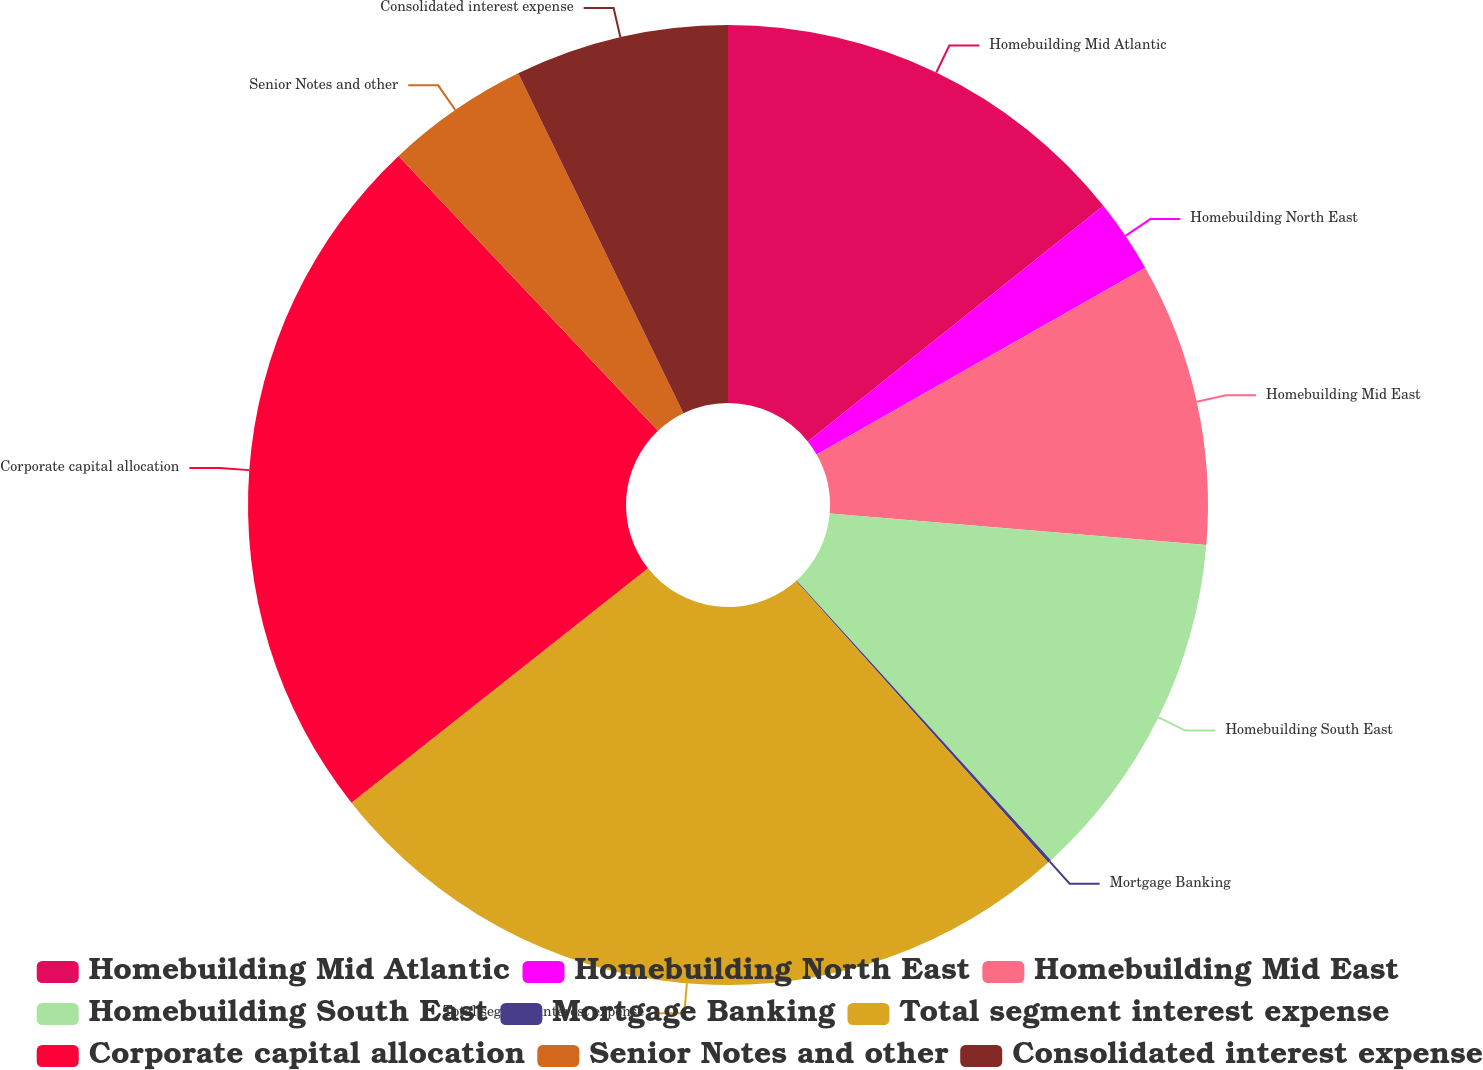<chart> <loc_0><loc_0><loc_500><loc_500><pie_chart><fcel>Homebuilding Mid Atlantic<fcel>Homebuilding North East<fcel>Homebuilding Mid East<fcel>Homebuilding South East<fcel>Mortgage Banking<fcel>Total segment interest expense<fcel>Corporate capital allocation<fcel>Senior Notes and other<fcel>Consolidated interest expense<nl><fcel>14.29%<fcel>2.48%<fcel>9.56%<fcel>11.93%<fcel>0.12%<fcel>25.98%<fcel>23.61%<fcel>4.84%<fcel>7.2%<nl></chart> 